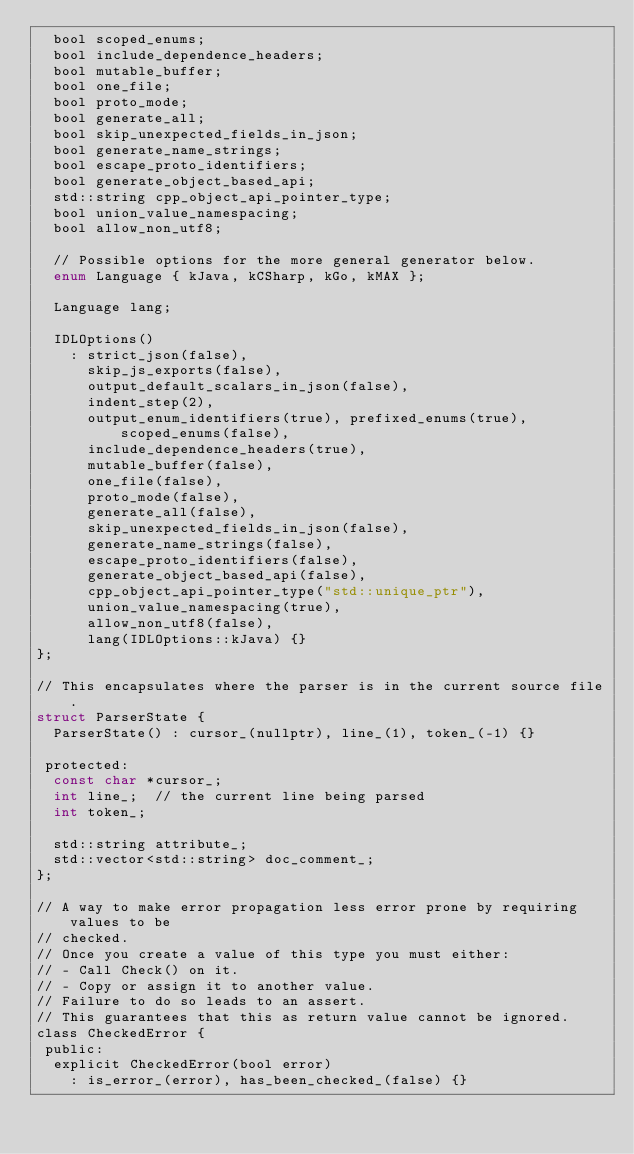Convert code to text. <code><loc_0><loc_0><loc_500><loc_500><_C_>  bool scoped_enums;
  bool include_dependence_headers;
  bool mutable_buffer;
  bool one_file;
  bool proto_mode;
  bool generate_all;
  bool skip_unexpected_fields_in_json;
  bool generate_name_strings;
  bool escape_proto_identifiers;
  bool generate_object_based_api;
  std::string cpp_object_api_pointer_type;
  bool union_value_namespacing;
  bool allow_non_utf8;

  // Possible options for the more general generator below.
  enum Language { kJava, kCSharp, kGo, kMAX };

  Language lang;

  IDLOptions()
    : strict_json(false),
      skip_js_exports(false),
      output_default_scalars_in_json(false),
      indent_step(2),
      output_enum_identifiers(true), prefixed_enums(true), scoped_enums(false),
      include_dependence_headers(true),
      mutable_buffer(false),
      one_file(false),
      proto_mode(false),
      generate_all(false),
      skip_unexpected_fields_in_json(false),
      generate_name_strings(false),
      escape_proto_identifiers(false),
      generate_object_based_api(false),
      cpp_object_api_pointer_type("std::unique_ptr"),
      union_value_namespacing(true),
      allow_non_utf8(false),
      lang(IDLOptions::kJava) {}
};

// This encapsulates where the parser is in the current source file.
struct ParserState {
  ParserState() : cursor_(nullptr), line_(1), token_(-1) {}

 protected:
  const char *cursor_;
  int line_;  // the current line being parsed
  int token_;

  std::string attribute_;
  std::vector<std::string> doc_comment_;
};

// A way to make error propagation less error prone by requiring values to be
// checked.
// Once you create a value of this type you must either:
// - Call Check() on it.
// - Copy or assign it to another value.
// Failure to do so leads to an assert.
// This guarantees that this as return value cannot be ignored.
class CheckedError {
 public:
  explicit CheckedError(bool error)
    : is_error_(error), has_been_checked_(false) {}
</code> 